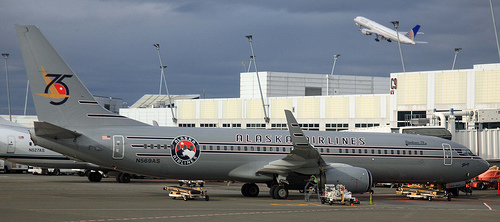Can you tell if the plane is at arrivals or departures? The airplane is parked at a gate which is a typical position for both arrival and departure. However, the closed door and lack of visible passenger activity might indicate that the airplane has recently arrived and is awaiting boarding for the next departure. 